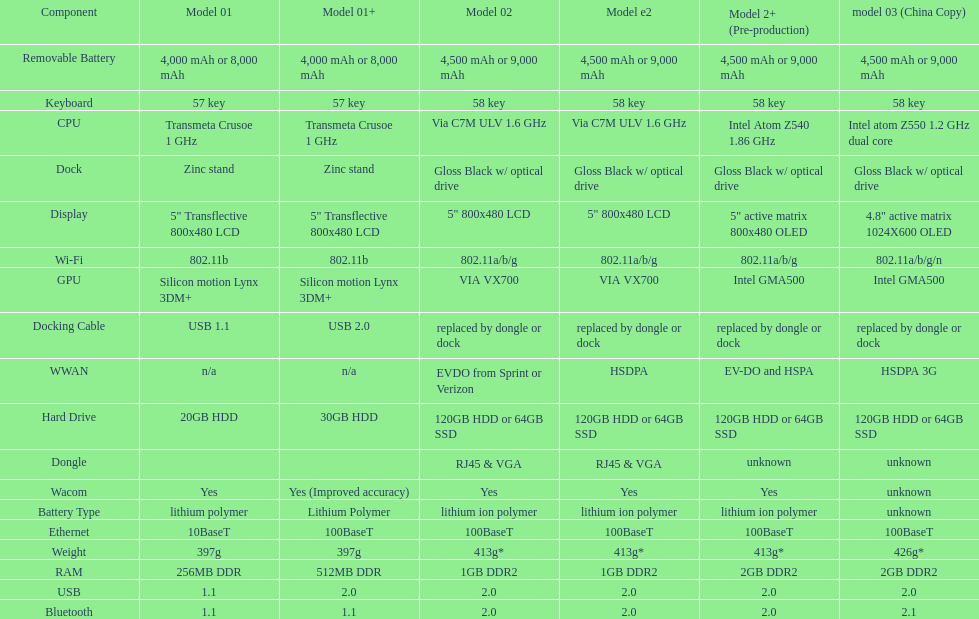What is the average number of models that have usb 2.0? 5. 